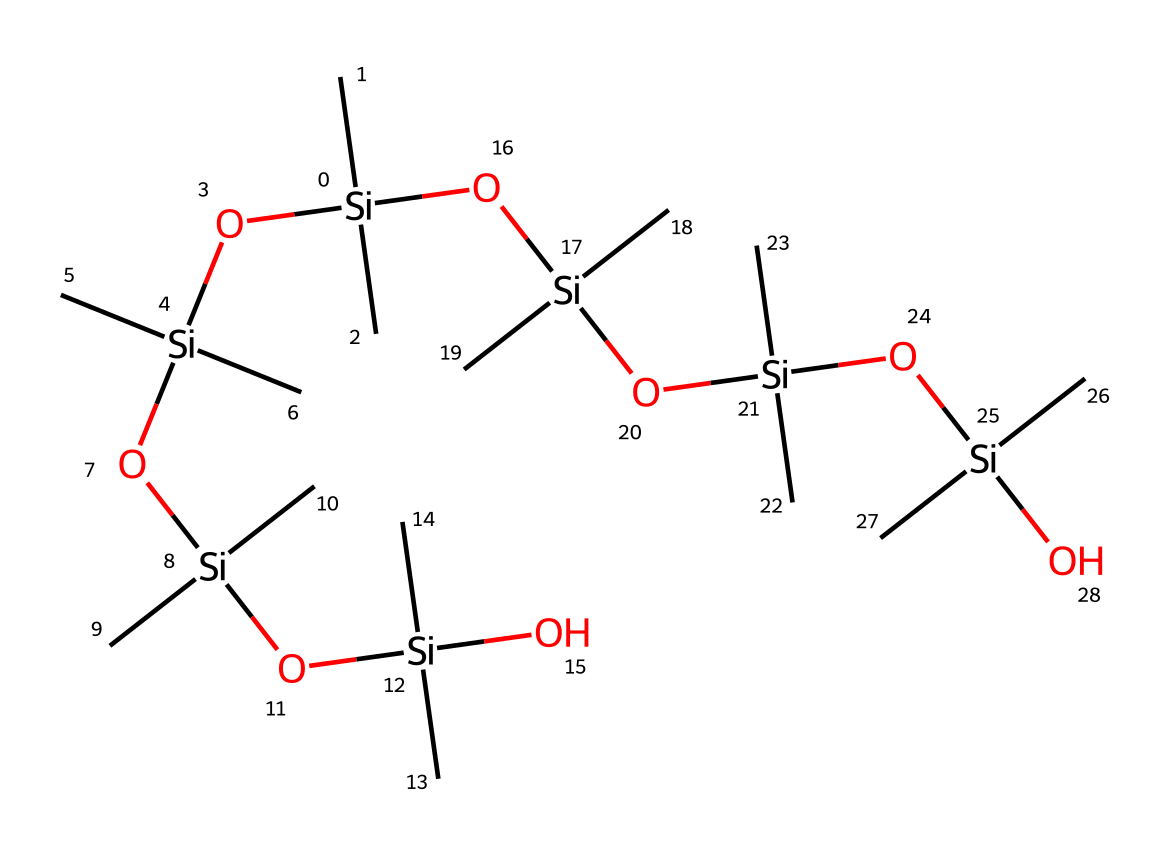What is the central atom in this chemical structure? The central atom in this chemical structure is silicon, observed in the multiple instances of "[Si]" throughout the SMILES notation.
Answer: silicon How many silicon atoms are present? By counting the occurrences of "[Si]" in the SMILES representation, we can see there are a total of 8 silicon atoms.
Answer: 8 What are the functional groups present in this compound? The functional groups visible in the structure include hydroxyl (-OH) and silanol groups. The presence of the "O" connected to silicon indicates these groups.
Answer: silanol How many oxygen atoms are in the structure? The structure contains multiple instances of oxygen connected to silicon, so counting these "O" occurrences leads to a total of 6 oxygen atoms.
Answer: 6 What type of polymer is suggested by the repetition in the structure? The repetitive nature of silicon and oxygen atoms indicates this is a polysiloxane, which is a type of silicone polymer typically used for its flexibility and low surface tension.
Answer: polysiloxane What property does the arrangement of silicon and oxygen in this structure suggest? The alternating silicon and oxygen atoms, characteristic of siloxane bonds, suggest properties like thermal stability and low surface tension, which contribute to its effectiveness as an anti-foaming agent.
Answer: thermal stability What is one potential application of this compound in the food industry? This compound is often used as an anti-foaming agent in sauces, helping to prevent excessive foaming during cooking or processing.
Answer: anti-foaming agent 